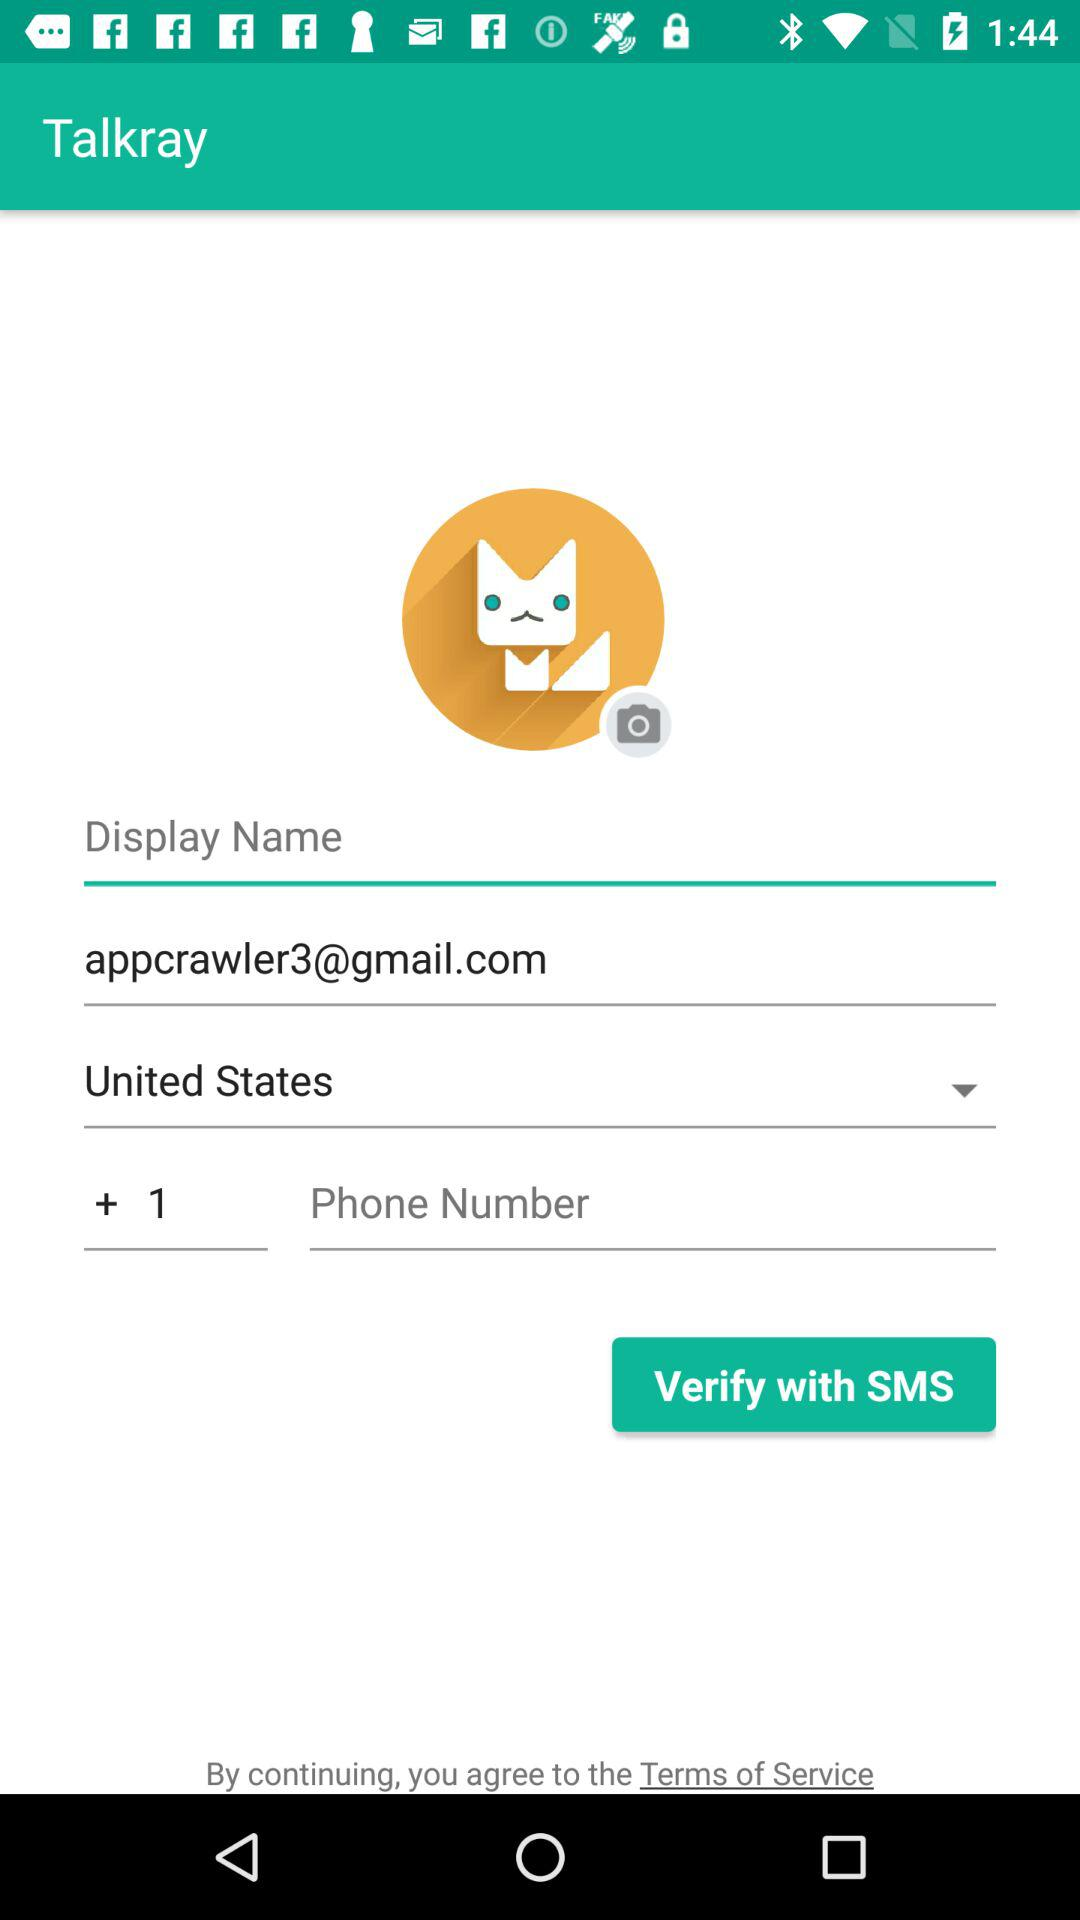What's the Gmail address used by the user for the application? The Gmail address used by the user for the application appcrawler3@gmail.com. 